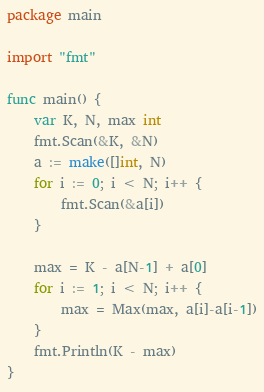Convert code to text. <code><loc_0><loc_0><loc_500><loc_500><_Go_>package main

import "fmt"

func main() {
	var K, N, max int
	fmt.Scan(&K, &N)
	a := make([]int, N)
	for i := 0; i < N; i++ {
		fmt.Scan(&a[i])
	}

	max = K - a[N-1] + a[0]
	for i := 1; i < N; i++ {
		max = Max(max, a[i]-a[i-1])
	}
	fmt.Println(K - max)
}
</code> 